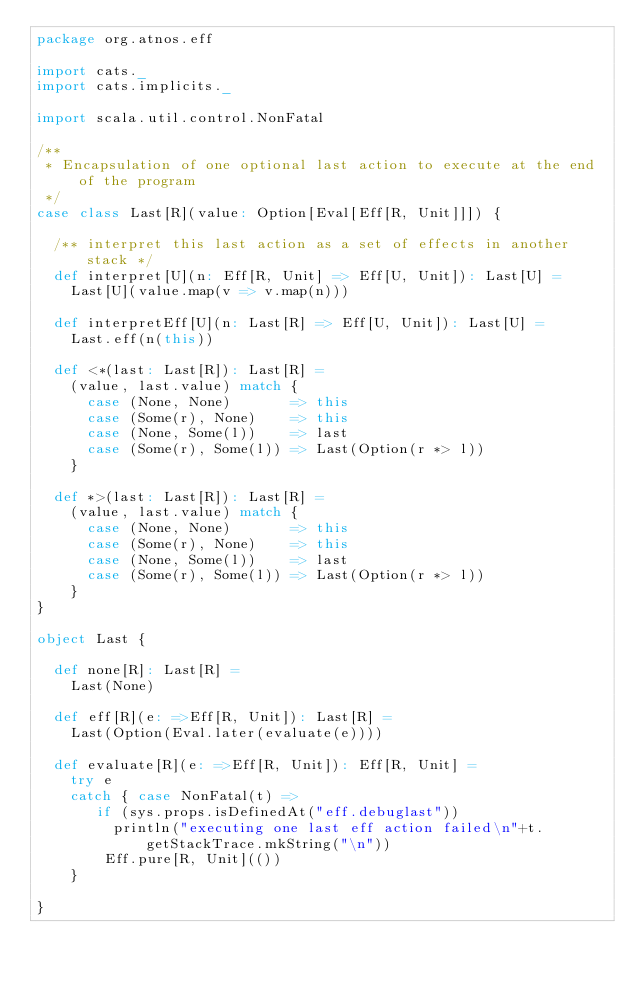Convert code to text. <code><loc_0><loc_0><loc_500><loc_500><_Scala_>package org.atnos.eff

import cats._
import cats.implicits._

import scala.util.control.NonFatal

/**
 * Encapsulation of one optional last action to execute at the end of the program
 */
case class Last[R](value: Option[Eval[Eff[R, Unit]]]) {

  /** interpret this last action as a set of effects in another stack */
  def interpret[U](n: Eff[R, Unit] => Eff[U, Unit]): Last[U] =
    Last[U](value.map(v => v.map(n)))

  def interpretEff[U](n: Last[R] => Eff[U, Unit]): Last[U] =
    Last.eff(n(this))

  def <*(last: Last[R]): Last[R] =
    (value, last.value) match {
      case (None, None)       => this
      case (Some(r), None)    => this
      case (None, Some(l))    => last
      case (Some(r), Some(l)) => Last(Option(r *> l))
    }

  def *>(last: Last[R]): Last[R] =
    (value, last.value) match {
      case (None, None)       => this
      case (Some(r), None)    => this
      case (None, Some(l))    => last
      case (Some(r), Some(l)) => Last(Option(r *> l))
    }
}

object Last {

  def none[R]: Last[R] =
    Last(None)

  def eff[R](e: =>Eff[R, Unit]): Last[R] =
    Last(Option(Eval.later(evaluate(e))))

  def evaluate[R](e: =>Eff[R, Unit]): Eff[R, Unit] =
    try e
    catch { case NonFatal(t) =>
       if (sys.props.isDefinedAt("eff.debuglast"))
         println("executing one last eff action failed\n"+t.getStackTrace.mkString("\n"))
        Eff.pure[R, Unit](())
    }

}
</code> 